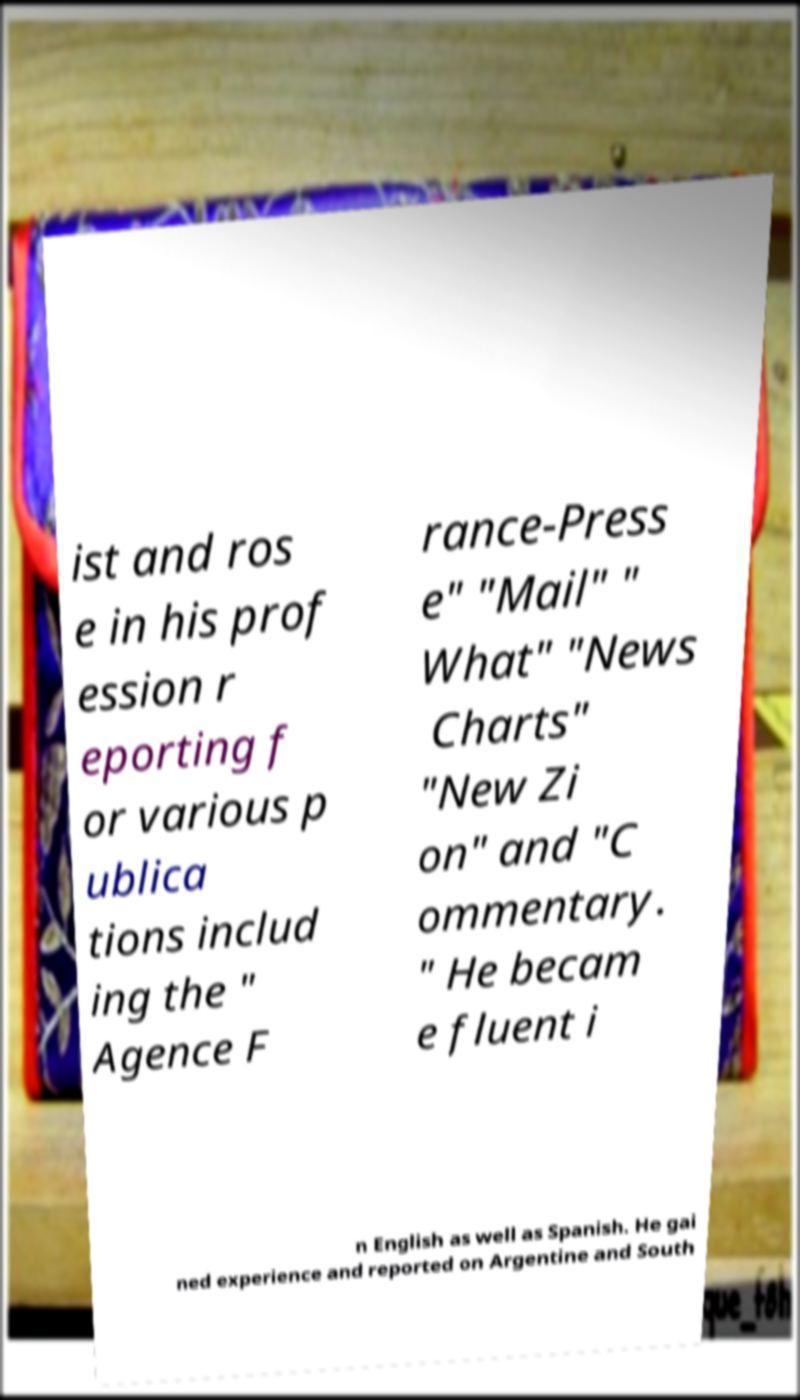For documentation purposes, I need the text within this image transcribed. Could you provide that? ist and ros e in his prof ession r eporting f or various p ublica tions includ ing the " Agence F rance-Press e" "Mail" " What" "News Charts" "New Zi on" and "C ommentary. " He becam e fluent i n English as well as Spanish. He gai ned experience and reported on Argentine and South 